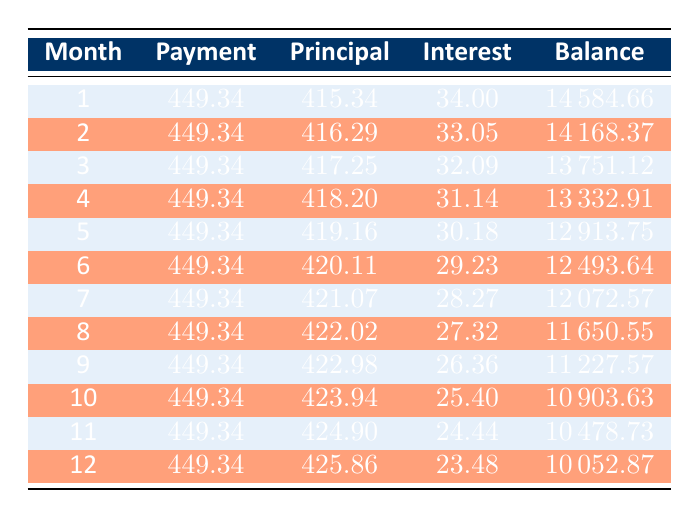What is the amount of the first principal payment? The first month's principal is listed in the table under the "Principal" column for month 1, which states it is 415.34.
Answer: 415.34 What is the total interest paid in the first three months? To find the total interest paid in the first three months, sum the interest values from those months: 34.00 (month 1) + 33.05 (month 2) + 32.09 (month 3) = 99.14.
Answer: 99.14 Is the monthly payment consistent throughout the term? Each month shows a payment of 449.34, indicating that the monthly payment remains consistent for the entire loan term.
Answer: Yes What is the remaining loan balance after 6 months? The remaining balance after 6 months is located in the "Balance" column for month 6, which is 12493.64.
Answer: 12493.64 How much principal do you pay in the month with the least principal paid? The month with the least principal payment is the first month, which shows a principal payment of 415.34.
Answer: 415.34 What is the total amount paid in interest over the first year? Sum the interest amounts for the first 12 months: 34.00 + 33.05 + 32.09 + 31.14 + 30.18 + 29.23 + 28.27 + 27.32 + 26.36 + 25.40 + 24.44 + 23.48 =  1,066.82.
Answer: 1,066.82 How much does the loan balance decrease after the first year? The initial loan amount was 15000, and after 12 months, the remaining balance is 10052.87. The decrease is calculated as 15000 - 10052.87 = 4947.13.
Answer: 4947.13 Which month shows the highest interest payment? The monthly interest payment decreases over time; the highest interest payment is recorded in the first month at 34.00.
Answer: 34.00 What is the difference in principal payment between the first and last month? The principal payment for month 1 is 415.34, and for month 12 it is 425.86. The difference is calculated as 425.86 - 415.34 = 10.52.
Answer: 10.52 